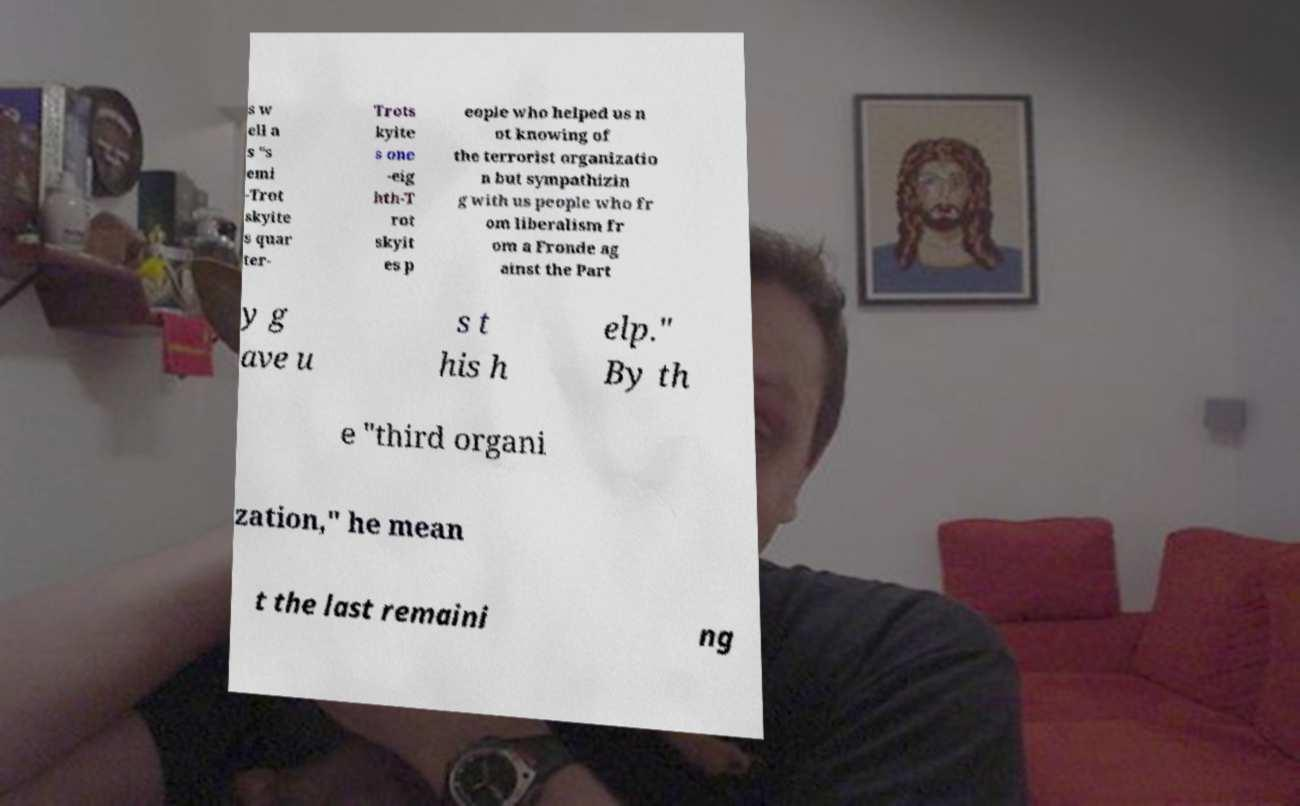Could you assist in decoding the text presented in this image and type it out clearly? s w ell a s "s emi -Trot skyite s quar ter- Trots kyite s one -eig hth-T rot skyit es p eople who helped us n ot knowing of the terrorist organizatio n but sympathizin g with us people who fr om liberalism fr om a Fronde ag ainst the Part y g ave u s t his h elp." By th e "third organi zation," he mean t the last remaini ng 